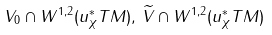<formula> <loc_0><loc_0><loc_500><loc_500>V _ { 0 } \cap W ^ { 1 , 2 } ( u _ { \chi } ^ { \ast } T M ) , \, \widetilde { V } \cap W ^ { 1 , 2 } ( u _ { \chi } ^ { \ast } T M )</formula> 